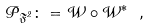<formula> <loc_0><loc_0><loc_500><loc_500>\mathcal { P } _ { \mathfrak { F } ^ { 2 } } \colon = \mathcal { W } \circ \mathcal { W } ^ { * } \ ,</formula> 